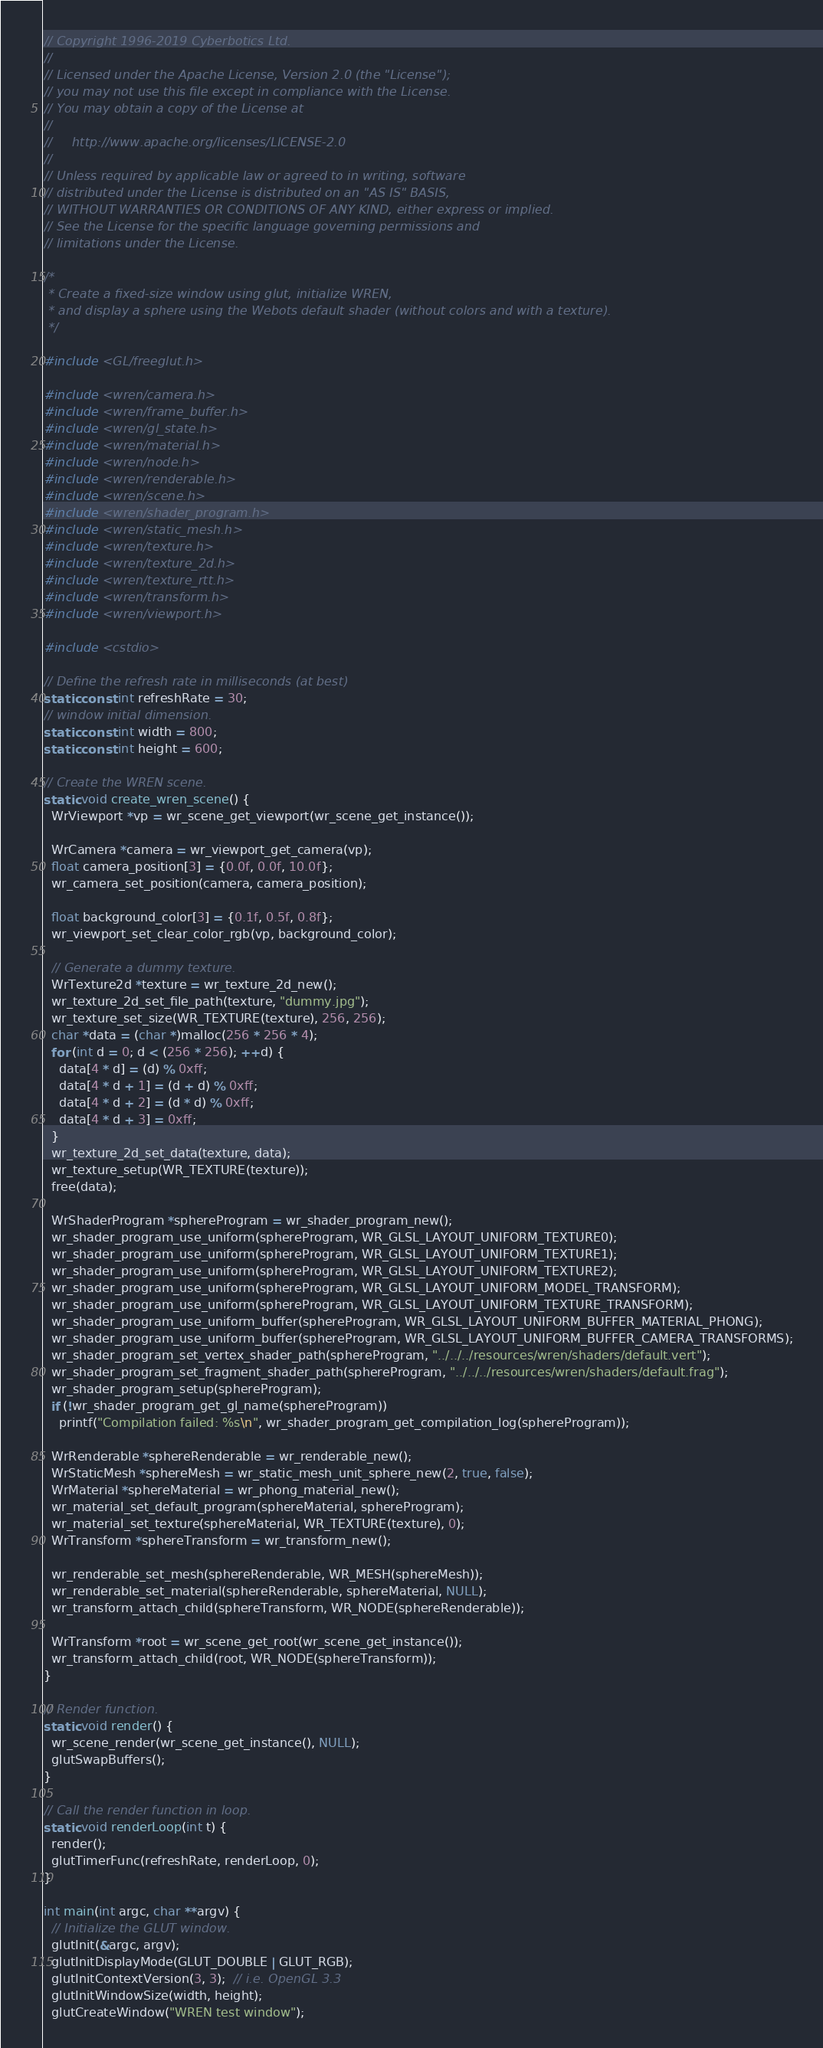Convert code to text. <code><loc_0><loc_0><loc_500><loc_500><_C++_>// Copyright 1996-2019 Cyberbotics Ltd.
//
// Licensed under the Apache License, Version 2.0 (the "License");
// you may not use this file except in compliance with the License.
// You may obtain a copy of the License at
//
//     http://www.apache.org/licenses/LICENSE-2.0
//
// Unless required by applicable law or agreed to in writing, software
// distributed under the License is distributed on an "AS IS" BASIS,
// WITHOUT WARRANTIES OR CONDITIONS OF ANY KIND, either express or implied.
// See the License for the specific language governing permissions and
// limitations under the License.

/*
 * Create a fixed-size window using glut, initialize WREN,
 * and display a sphere using the Webots default shader (without colors and with a texture).
 */

#include <GL/freeglut.h>

#include <wren/camera.h>
#include <wren/frame_buffer.h>
#include <wren/gl_state.h>
#include <wren/material.h>
#include <wren/node.h>
#include <wren/renderable.h>
#include <wren/scene.h>
#include <wren/shader_program.h>
#include <wren/static_mesh.h>
#include <wren/texture.h>
#include <wren/texture_2d.h>
#include <wren/texture_rtt.h>
#include <wren/transform.h>
#include <wren/viewport.h>

#include <cstdio>

// Define the refresh rate in milliseconds (at best)
static const int refreshRate = 30;
// window initial dimension.
static const int width = 800;
static const int height = 600;

// Create the WREN scene.
static void create_wren_scene() {
  WrViewport *vp = wr_scene_get_viewport(wr_scene_get_instance());

  WrCamera *camera = wr_viewport_get_camera(vp);
  float camera_position[3] = {0.0f, 0.0f, 10.0f};
  wr_camera_set_position(camera, camera_position);

  float background_color[3] = {0.1f, 0.5f, 0.8f};
  wr_viewport_set_clear_color_rgb(vp, background_color);

  // Generate a dummy texture.
  WrTexture2d *texture = wr_texture_2d_new();
  wr_texture_2d_set_file_path(texture, "dummy.jpg");
  wr_texture_set_size(WR_TEXTURE(texture), 256, 256);
  char *data = (char *)malloc(256 * 256 * 4);
  for (int d = 0; d < (256 * 256); ++d) {
    data[4 * d] = (d) % 0xff;
    data[4 * d + 1] = (d + d) % 0xff;
    data[4 * d + 2] = (d * d) % 0xff;
    data[4 * d + 3] = 0xff;
  }
  wr_texture_2d_set_data(texture, data);
  wr_texture_setup(WR_TEXTURE(texture));
  free(data);

  WrShaderProgram *sphereProgram = wr_shader_program_new();
  wr_shader_program_use_uniform(sphereProgram, WR_GLSL_LAYOUT_UNIFORM_TEXTURE0);
  wr_shader_program_use_uniform(sphereProgram, WR_GLSL_LAYOUT_UNIFORM_TEXTURE1);
  wr_shader_program_use_uniform(sphereProgram, WR_GLSL_LAYOUT_UNIFORM_TEXTURE2);
  wr_shader_program_use_uniform(sphereProgram, WR_GLSL_LAYOUT_UNIFORM_MODEL_TRANSFORM);
  wr_shader_program_use_uniform(sphereProgram, WR_GLSL_LAYOUT_UNIFORM_TEXTURE_TRANSFORM);
  wr_shader_program_use_uniform_buffer(sphereProgram, WR_GLSL_LAYOUT_UNIFORM_BUFFER_MATERIAL_PHONG);
  wr_shader_program_use_uniform_buffer(sphereProgram, WR_GLSL_LAYOUT_UNIFORM_BUFFER_CAMERA_TRANSFORMS);
  wr_shader_program_set_vertex_shader_path(sphereProgram, "../../../resources/wren/shaders/default.vert");
  wr_shader_program_set_fragment_shader_path(sphereProgram, "../../../resources/wren/shaders/default.frag");
  wr_shader_program_setup(sphereProgram);
  if (!wr_shader_program_get_gl_name(sphereProgram))
    printf("Compilation failed: %s\n", wr_shader_program_get_compilation_log(sphereProgram));

  WrRenderable *sphereRenderable = wr_renderable_new();
  WrStaticMesh *sphereMesh = wr_static_mesh_unit_sphere_new(2, true, false);
  WrMaterial *sphereMaterial = wr_phong_material_new();
  wr_material_set_default_program(sphereMaterial, sphereProgram);
  wr_material_set_texture(sphereMaterial, WR_TEXTURE(texture), 0);
  WrTransform *sphereTransform = wr_transform_new();

  wr_renderable_set_mesh(sphereRenderable, WR_MESH(sphereMesh));
  wr_renderable_set_material(sphereRenderable, sphereMaterial, NULL);
  wr_transform_attach_child(sphereTransform, WR_NODE(sphereRenderable));

  WrTransform *root = wr_scene_get_root(wr_scene_get_instance());
  wr_transform_attach_child(root, WR_NODE(sphereTransform));
}

// Render function.
static void render() {
  wr_scene_render(wr_scene_get_instance(), NULL);
  glutSwapBuffers();
}

// Call the render function in loop.
static void renderLoop(int t) {
  render();
  glutTimerFunc(refreshRate, renderLoop, 0);
}

int main(int argc, char **argv) {
  // Initialize the GLUT window.
  glutInit(&argc, argv);
  glutInitDisplayMode(GLUT_DOUBLE | GLUT_RGB);
  glutInitContextVersion(3, 3);  // i.e. OpenGL 3.3
  glutInitWindowSize(width, height);
  glutCreateWindow("WREN test window");
</code> 